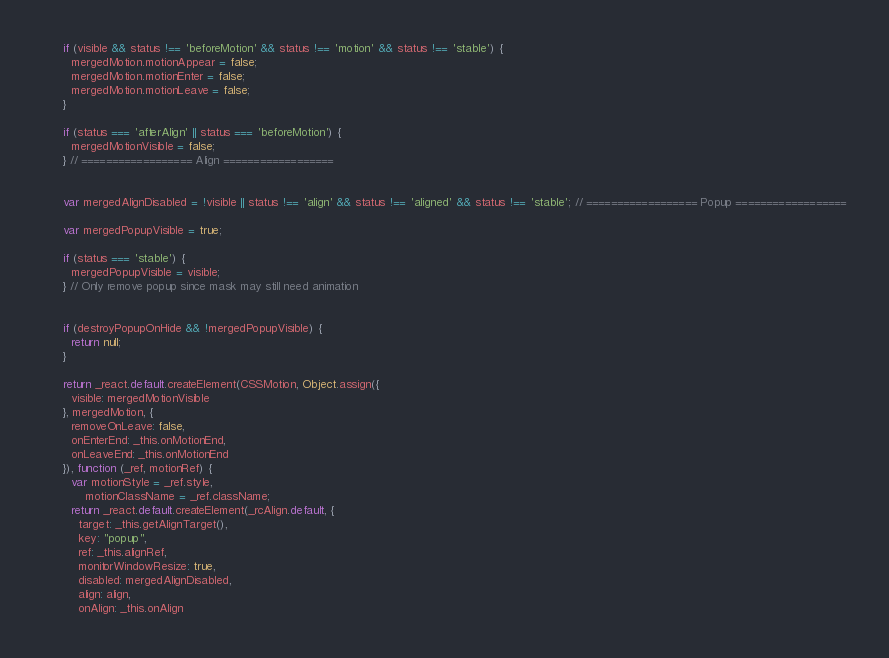Convert code to text. <code><loc_0><loc_0><loc_500><loc_500><_JavaScript_>      if (visible && status !== 'beforeMotion' && status !== 'motion' && status !== 'stable') {
        mergedMotion.motionAppear = false;
        mergedMotion.motionEnter = false;
        mergedMotion.motionLeave = false;
      }

      if (status === 'afterAlign' || status === 'beforeMotion') {
        mergedMotionVisible = false;
      } // ================== Align ==================


      var mergedAlignDisabled = !visible || status !== 'align' && status !== 'aligned' && status !== 'stable'; // ================== Popup ==================

      var mergedPopupVisible = true;

      if (status === 'stable') {
        mergedPopupVisible = visible;
      } // Only remove popup since mask may still need animation


      if (destroyPopupOnHide && !mergedPopupVisible) {
        return null;
      }

      return _react.default.createElement(CSSMotion, Object.assign({
        visible: mergedMotionVisible
      }, mergedMotion, {
        removeOnLeave: false,
        onEnterEnd: _this.onMotionEnd,
        onLeaveEnd: _this.onMotionEnd
      }), function (_ref, motionRef) {
        var motionStyle = _ref.style,
            motionClassName = _ref.className;
        return _react.default.createElement(_rcAlign.default, {
          target: _this.getAlignTarget(),
          key: "popup",
          ref: _this.alignRef,
          monitorWindowResize: true,
          disabled: mergedAlignDisabled,
          align: align,
          onAlign: _this.onAlign</code> 